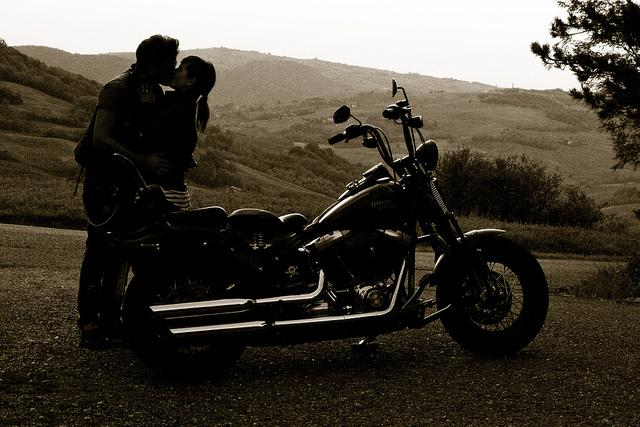What are the two feeling right now? Please explain your reasoning. attraction. The people are embracing in a loving hug. 